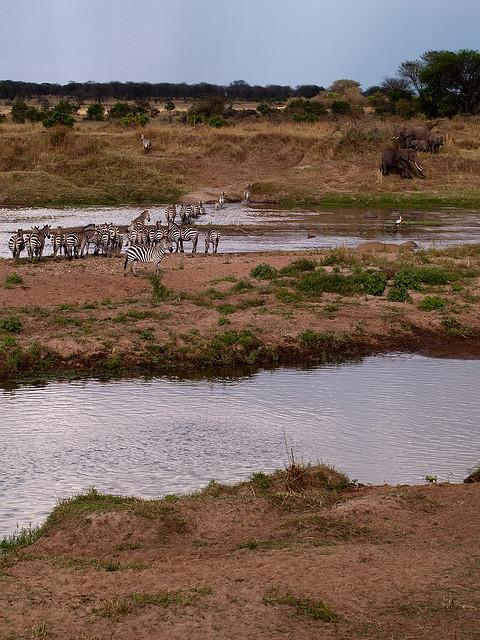How many birds are standing inside of the river with the zebras on the island? one 